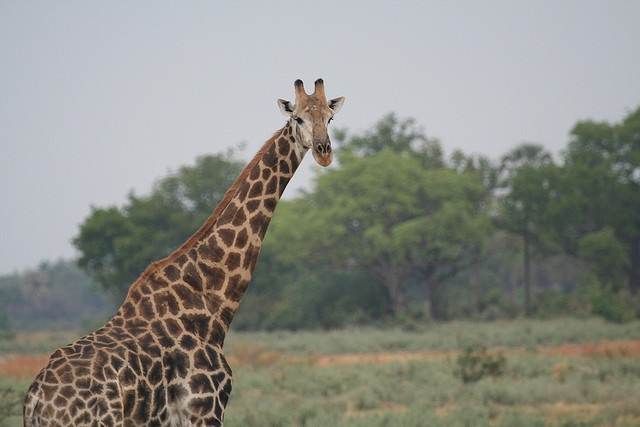Describe the objects in this image and their specific colors. I can see a giraffe in darkgray, maroon, gray, and black tones in this image. 